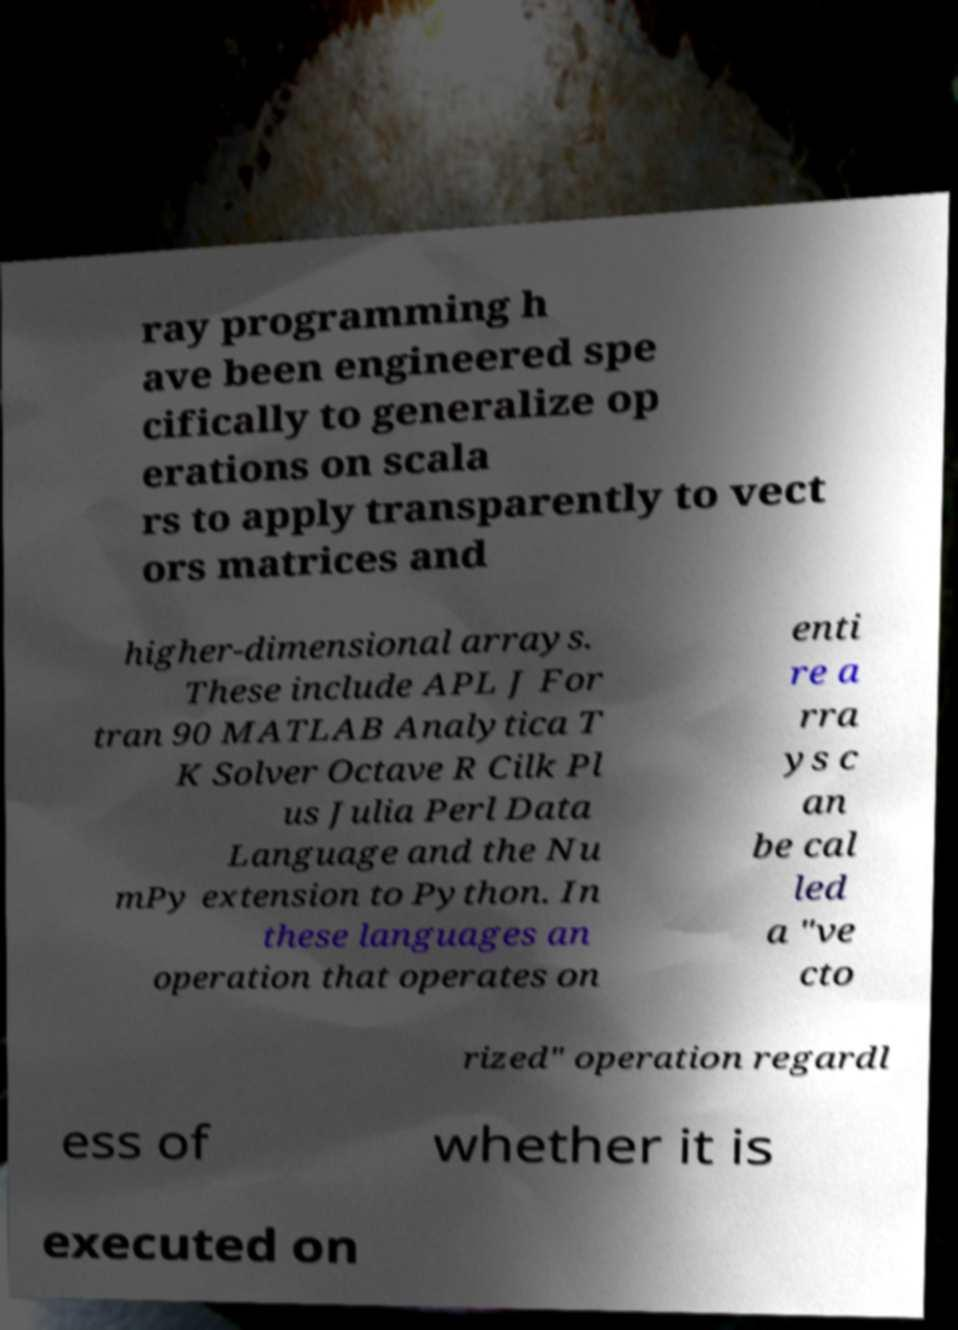Please read and relay the text visible in this image. What does it say? ray programming h ave been engineered spe cifically to generalize op erations on scala rs to apply transparently to vect ors matrices and higher-dimensional arrays. These include APL J For tran 90 MATLAB Analytica T K Solver Octave R Cilk Pl us Julia Perl Data Language and the Nu mPy extension to Python. In these languages an operation that operates on enti re a rra ys c an be cal led a "ve cto rized" operation regardl ess of whether it is executed on 